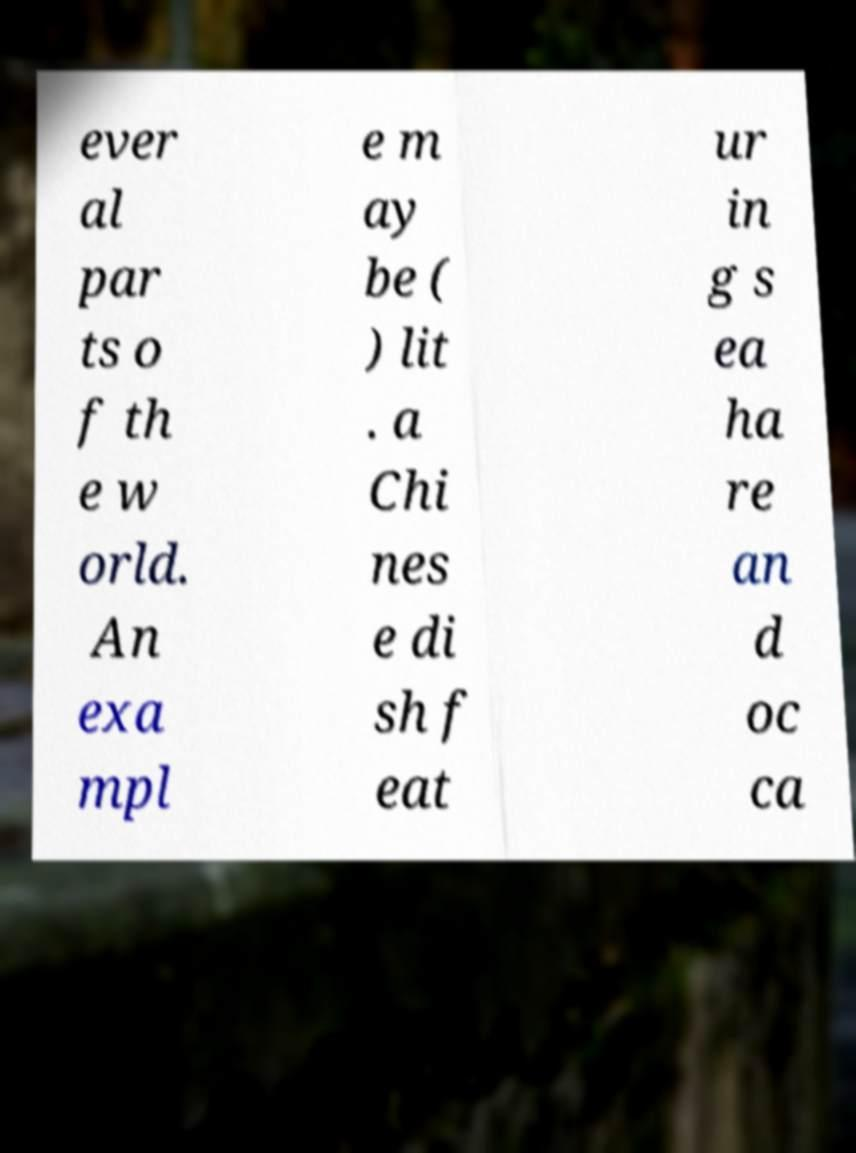There's text embedded in this image that I need extracted. Can you transcribe it verbatim? ever al par ts o f th e w orld. An exa mpl e m ay be ( ) lit . a Chi nes e di sh f eat ur in g s ea ha re an d oc ca 